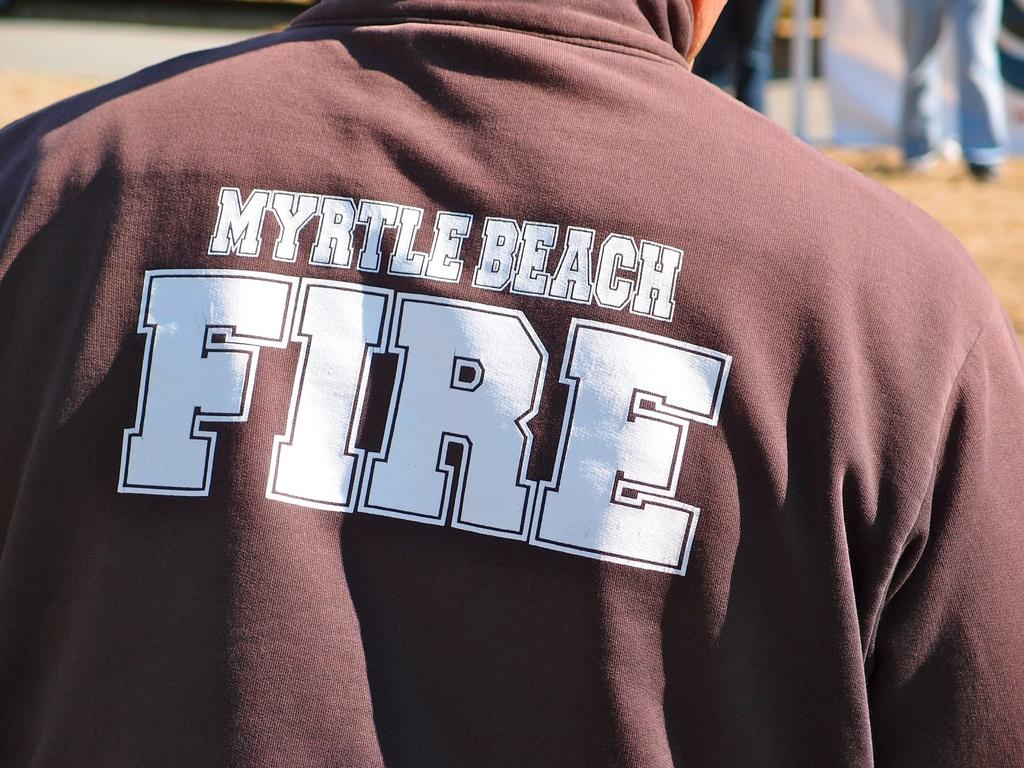<image>
Render a clear and concise summary of the photo. The back of a shirt has the word fire on it. 